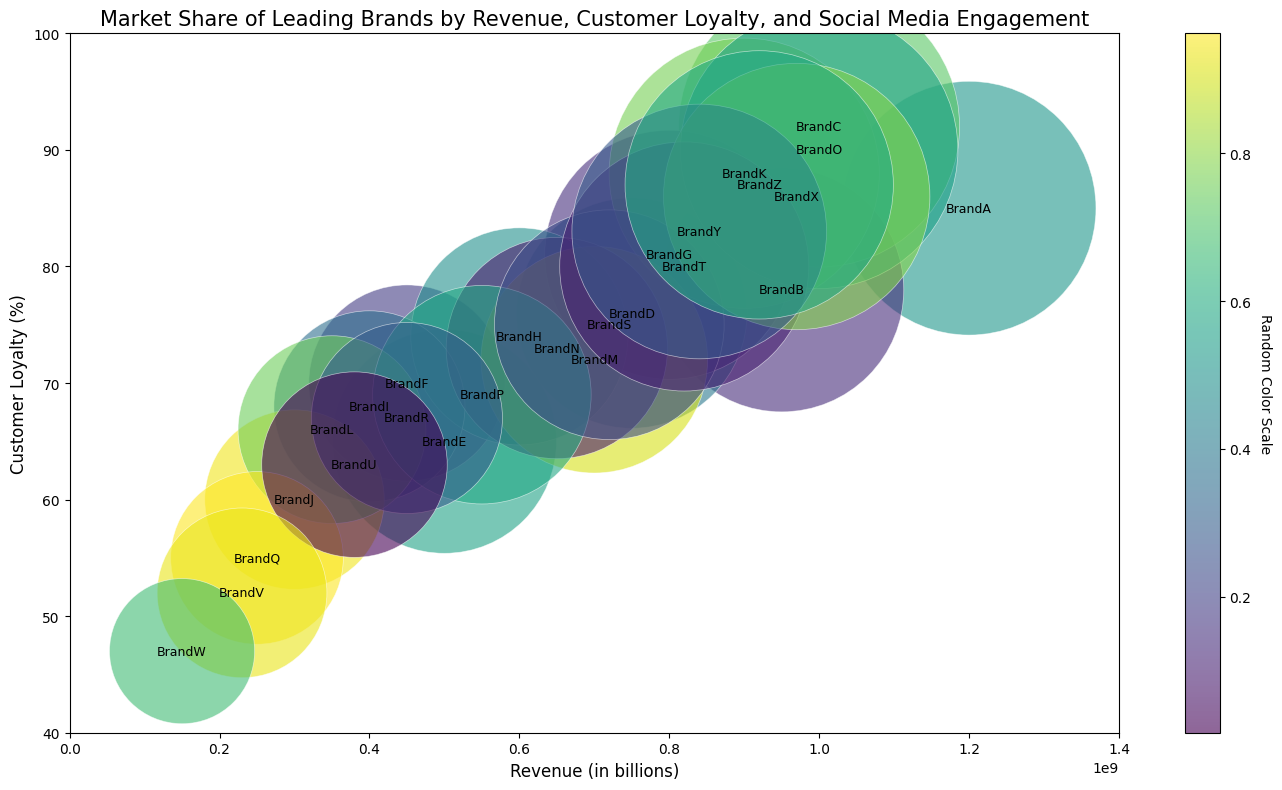Which brand has the highest revenue? By looking at the x-axis (Revenue) and identifying the brand placed farthest to the right, we determine the brand with the highest value.
Answer: BrandA What is the average customer loyalty percentage for the brands with revenue less than $600,000,000? To find this, identify the brands situated left of the 600,000,000 mark on the x-axis. The relevant brands are BrandJ, BrandL, BrandP, BrandR, BrandU, BrandV, and BrandW. Their customer loyalties are 60, 66, 69, 67, 63, 52, and 47. (60+66+69+67+63+52+47)/7 = 60.57.
Answer: 60.57 Which brand has the largest bubble size, indicating the highest social media engagement? Bubble size represents social media engagement. Locate the largest bubble.
Answer: BrandC Do brands with higher customer loyalty generally have higher revenues? Compare the overall trend of the points. In general, brands positioned higher on the plot (higher customer loyalty) also trend to the right (higher revenue). This indicates a positive correlation.
Answer: Yes Which brand is more loyal, BrandE or BrandI? Identify the position of BrandE and BrandI on the y-axis. BrandE has a loyalty of 65, and BrandI has 68.
Answer: BrandI Among brands in the revenue range $800,000,000 to $1,000,000,000, which one has the lowest social media engagement? Brands in this range are BrandG, BrandT, BrandK, BrandX, BrandO, and BrandB. Check bubble sizes (BrandB: 1,200,000). Compare these sizes to determine the smallest.
Answer: BrandB What is the combined revenue of BrandC and BrandO? Add the revenue values of BrandC ($1,000,000,000) and BrandO ($1,000,000,000).
Answer: $2,000,000,000 Which brand has a customer loyalty percentage closest to the average customer loyalty percentage? Calculate the average loyalty for all brands: (85+78+92+76+65+70+81+74+68+60+88+66+72+73+90+69+55+67+75+80+63+52+47+86+83+87)/26 = 73.38. Identify the brand nearest to this value.
Answer: BrandN What is the range of social media engagements for the brands displayed? Identify the smallest and largest bubble sizes representing engagement. The smallest is BrandW (150,000), and the largest is BrandC (2,100,000).
Answer: 1,950,000 